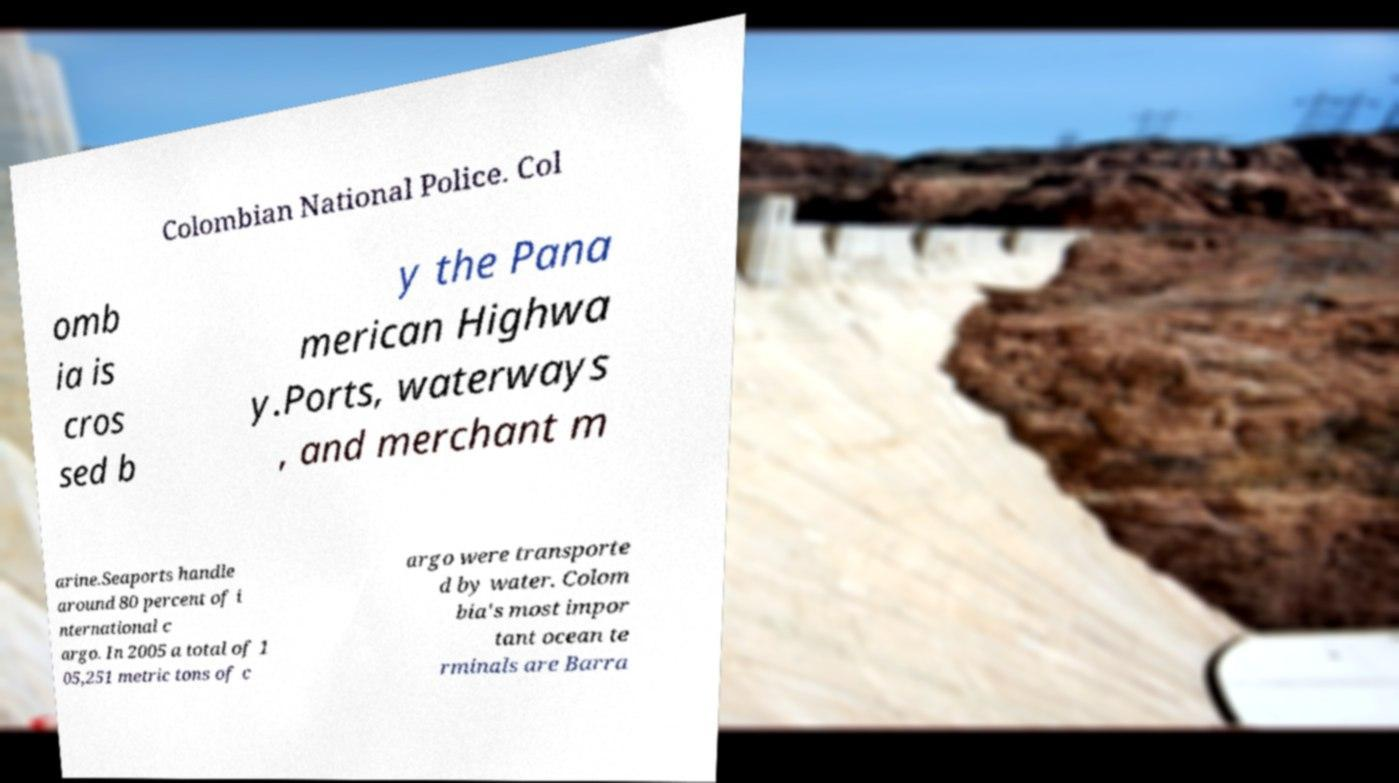Could you assist in decoding the text presented in this image and type it out clearly? Colombian National Police. Col omb ia is cros sed b y the Pana merican Highwa y.Ports, waterways , and merchant m arine.Seaports handle around 80 percent of i nternational c argo. In 2005 a total of 1 05,251 metric tons of c argo were transporte d by water. Colom bia's most impor tant ocean te rminals are Barra 